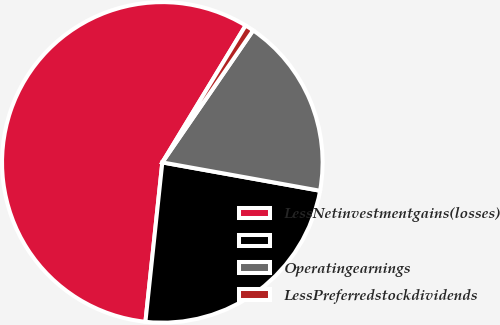<chart> <loc_0><loc_0><loc_500><loc_500><pie_chart><fcel>LessNetinvestmentgains(losses)<fcel>Unnamed: 1<fcel>Operatingearnings<fcel>LessPreferredstockdividends<nl><fcel>57.01%<fcel>23.85%<fcel>18.24%<fcel>0.89%<nl></chart> 